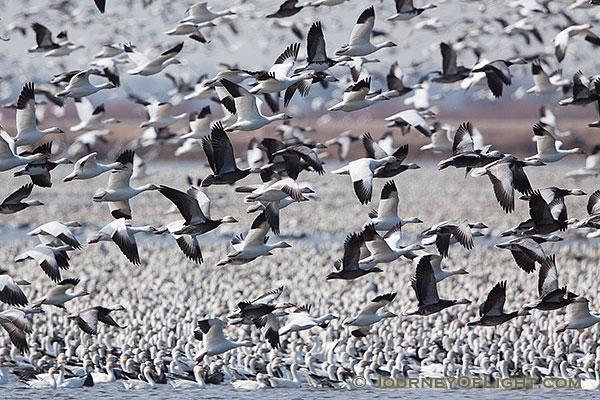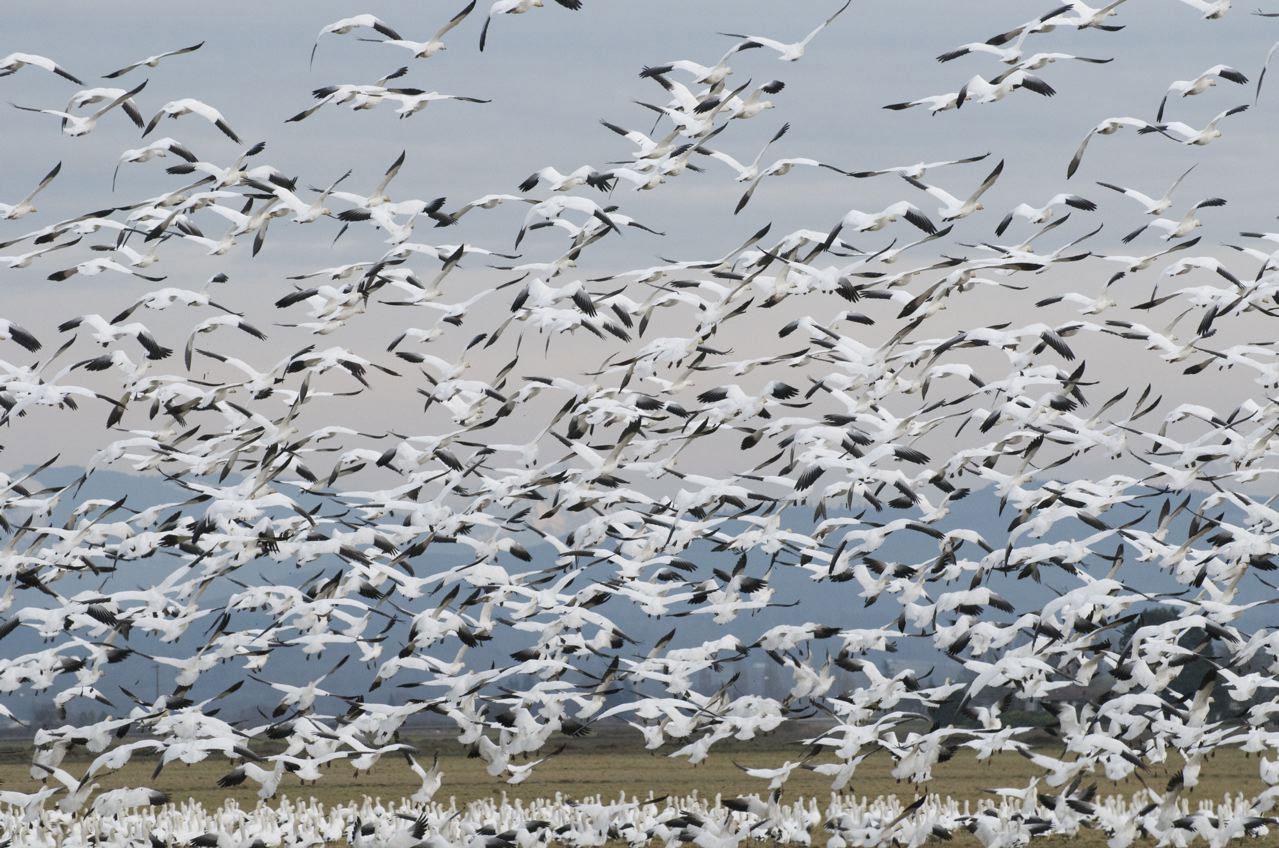The first image is the image on the left, the second image is the image on the right. Analyze the images presented: Is the assertion "There are several birds swimming in the water near the bottom on the image on the left." valid? Answer yes or no. Yes. 